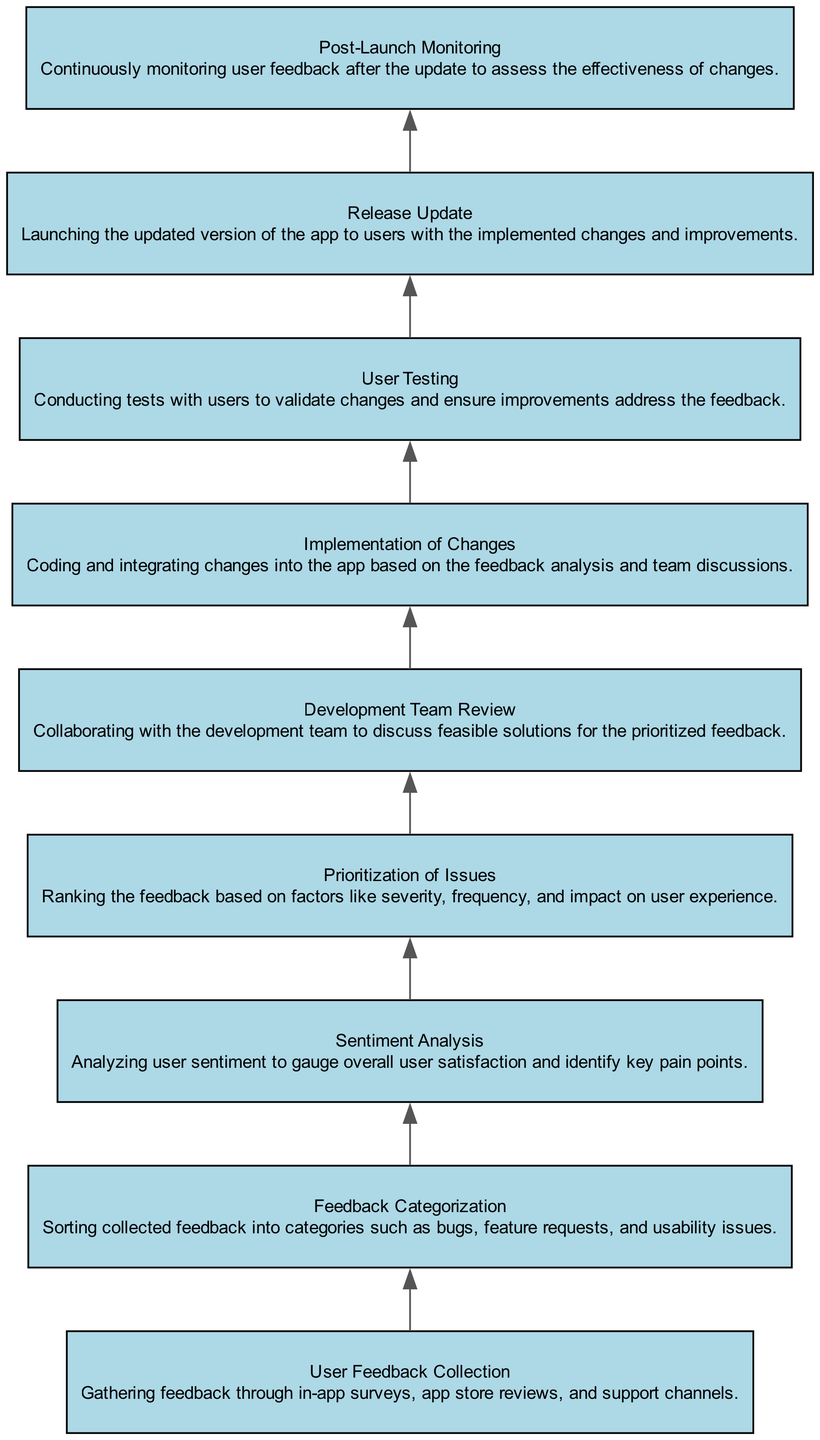What is the first step in the flow chart? The first node in the flow chart represents the "User Feedback Collection", which is the initial step of the process.
Answer: User Feedback Collection How many nodes are in the diagram? The diagram consists of 9 nodes, each representing a different step in the process of analyzing user feedback.
Answer: 9 Which step follows 'Sentiment Analysis'? The flow chart shows that 'Prioritization of Issues' directly follows 'Sentiment Analysis', indicating it is the next step in the process.
Answer: Prioritization of Issues What type of feedback is categorized in the 'Feedback Categorization' step? In this step, feedback is sorted into categories including bugs, feature requests, and usability issues, providing a structured evaluation of user input.
Answer: Bugs, feature requests, usability issues What is the relationship between 'Implementation of Changes' and 'User Testing'? 'User Testing' follows 'Implementation of Changes', which means that testing occurs after changes have been made to ensure they effectively address the feedback received.
Answer: User Testing follows Implementation of Changes Which step is the last in the flow chart? The last node in the flow chart is 'Post-Launch Monitoring', indicating the concluding step after the release of updates, focusing on ongoing feedback evaluation.
Answer: Post-Launch Monitoring How does 'Development Team Review' relate to 'Prioritization of Issues'? 'Development Team Review' occurs after 'Prioritization of Issues', indicating that the team discusses solutions for only the prioritized feedback issues that were categorized earlier.
Answer: Development Team Review follows Prioritization of Issues What process occurs immediately before 'Release Update'? The 'User Testing' step, which validates the changes made based on feedback, occurs immediately before the 'Release Update' step where the app is launched with those changes.
Answer: User Testing What feedback type is primarily assessed through 'Sentiment Analysis'? The 'Sentiment Analysis' step primarily assesses overall user satisfaction, providing insights into user feelings regarding the app's performance and features.
Answer: Overall user satisfaction 